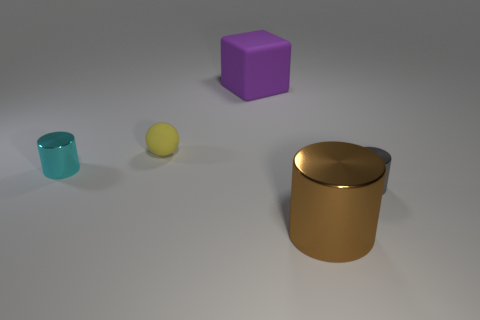Subtract all cyan metal cylinders. How many cylinders are left? 2 Add 3 big metal things. How many objects exist? 8 Subtract all brown cylinders. How many cylinders are left? 2 Subtract all gray metal things. Subtract all large rubber blocks. How many objects are left? 3 Add 5 cylinders. How many cylinders are left? 8 Add 1 cyan shiny things. How many cyan shiny things exist? 2 Subtract 0 purple cylinders. How many objects are left? 5 Subtract all blocks. How many objects are left? 4 Subtract 3 cylinders. How many cylinders are left? 0 Subtract all green spheres. Subtract all yellow cylinders. How many spheres are left? 1 